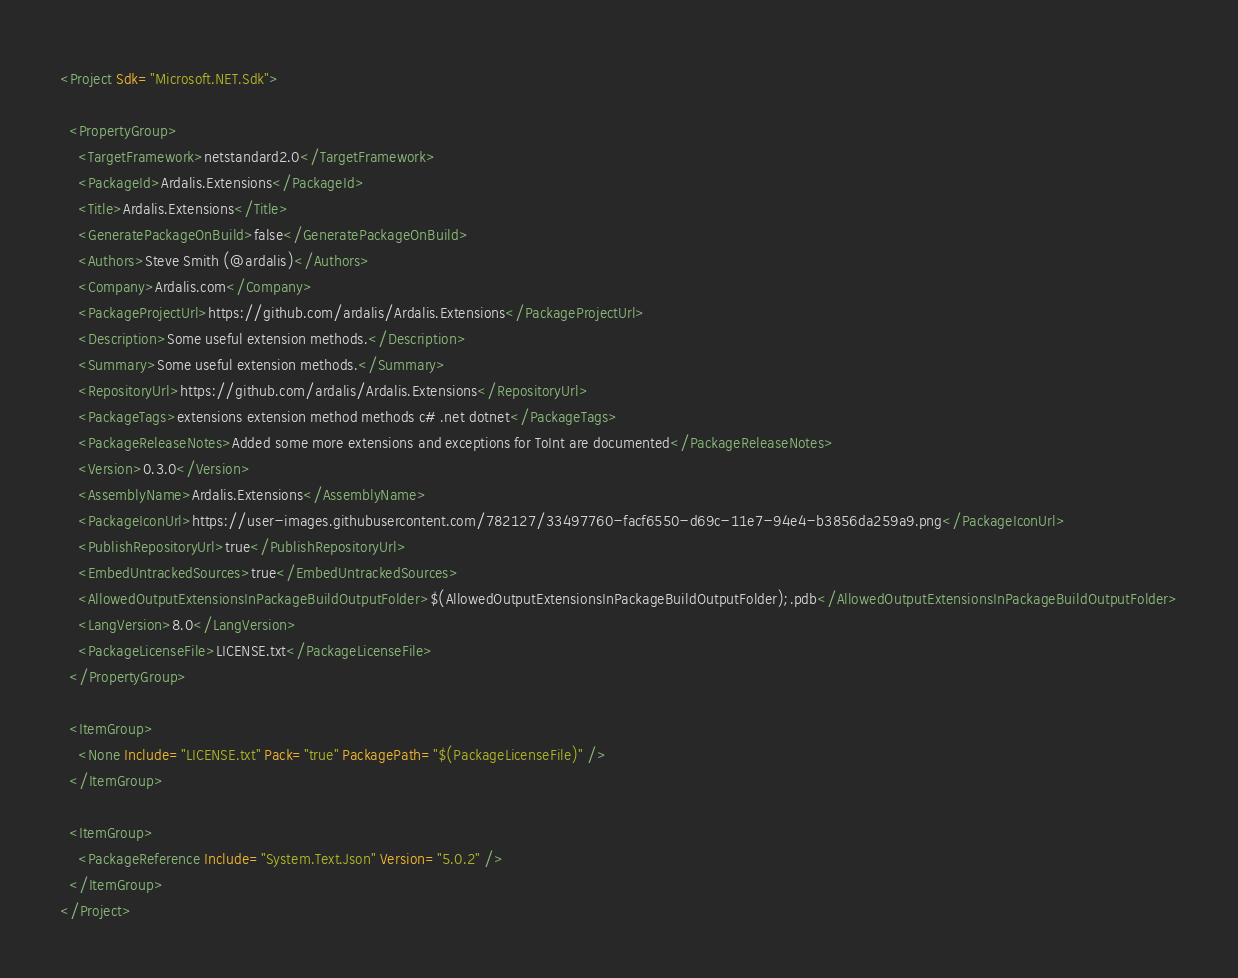<code> <loc_0><loc_0><loc_500><loc_500><_XML_><Project Sdk="Microsoft.NET.Sdk">

  <PropertyGroup>
    <TargetFramework>netstandard2.0</TargetFramework>
    <PackageId>Ardalis.Extensions</PackageId>
    <Title>Ardalis.Extensions</Title>
    <GeneratePackageOnBuild>false</GeneratePackageOnBuild>
    <Authors>Steve Smith (@ardalis)</Authors>
    <Company>Ardalis.com</Company>
    <PackageProjectUrl>https://github.com/ardalis/Ardalis.Extensions</PackageProjectUrl>
    <Description>Some useful extension methods.</Description>
    <Summary>Some useful extension methods.</Summary>
    <RepositoryUrl>https://github.com/ardalis/Ardalis.Extensions</RepositoryUrl>
    <PackageTags>extensions extension method methods c# .net dotnet</PackageTags>
    <PackageReleaseNotes>Added some more extensions and exceptions for ToInt are documented</PackageReleaseNotes>
    <Version>0.3.0</Version>
    <AssemblyName>Ardalis.Extensions</AssemblyName>
    <PackageIconUrl>https://user-images.githubusercontent.com/782127/33497760-facf6550-d69c-11e7-94e4-b3856da259a9.png</PackageIconUrl>
    <PublishRepositoryUrl>true</PublishRepositoryUrl>
    <EmbedUntrackedSources>true</EmbedUntrackedSources>
    <AllowedOutputExtensionsInPackageBuildOutputFolder>$(AllowedOutputExtensionsInPackageBuildOutputFolder);.pdb</AllowedOutputExtensionsInPackageBuildOutputFolder>
    <LangVersion>8.0</LangVersion>
    <PackageLicenseFile>LICENSE.txt</PackageLicenseFile>    
  </PropertyGroup>
  
  <ItemGroup>
    <None Include="LICENSE.txt" Pack="true" PackagePath="$(PackageLicenseFile)" />
  </ItemGroup>
  
  <ItemGroup>
    <PackageReference Include="System.Text.Json" Version="5.0.2" />
  </ItemGroup>
</Project>
</code> 